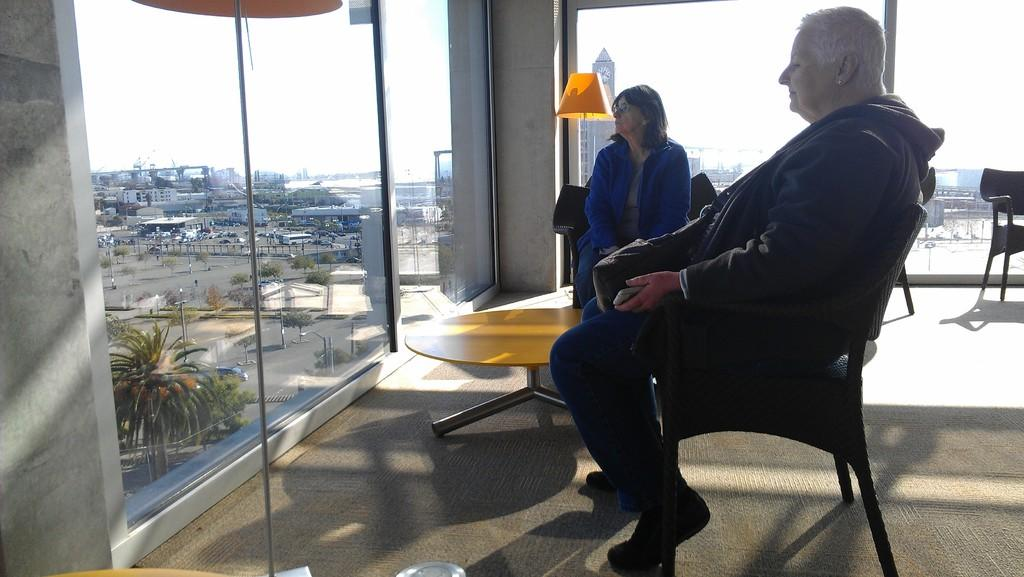How many people are in the image? There are two old women in the image. What are the women doing in the image? The women are looking at the road. What is in front of the women? There is a table in front of the women. What is located behind the women? There is a lump behind the women. What type of structures can be seen in the image? There are buildings visible in the image. What is the condition of the sky in the image? The sky is clear in the image. What type of belief is being discussed by the women in the image? There is no indication in the image that the women are discussing any beliefs. How many horses are visible in the image? There are no horses present in the image. 